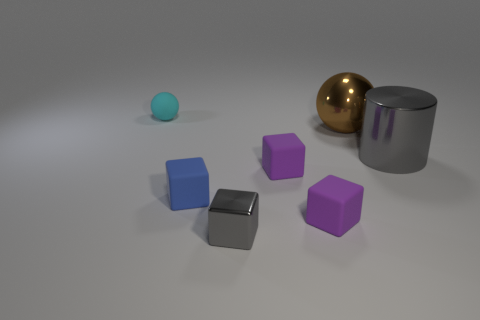Subtract all purple blocks. How many were subtracted if there are1purple blocks left? 1 Subtract 2 blocks. How many blocks are left? 2 Subtract all brown cubes. Subtract all blue balls. How many cubes are left? 4 Add 2 small gray blocks. How many objects exist? 9 Subtract 1 gray cubes. How many objects are left? 6 Subtract all spheres. How many objects are left? 5 Subtract all metal cylinders. Subtract all purple cubes. How many objects are left? 4 Add 5 small blue things. How many small blue things are left? 6 Add 1 large metal cylinders. How many large metal cylinders exist? 2 